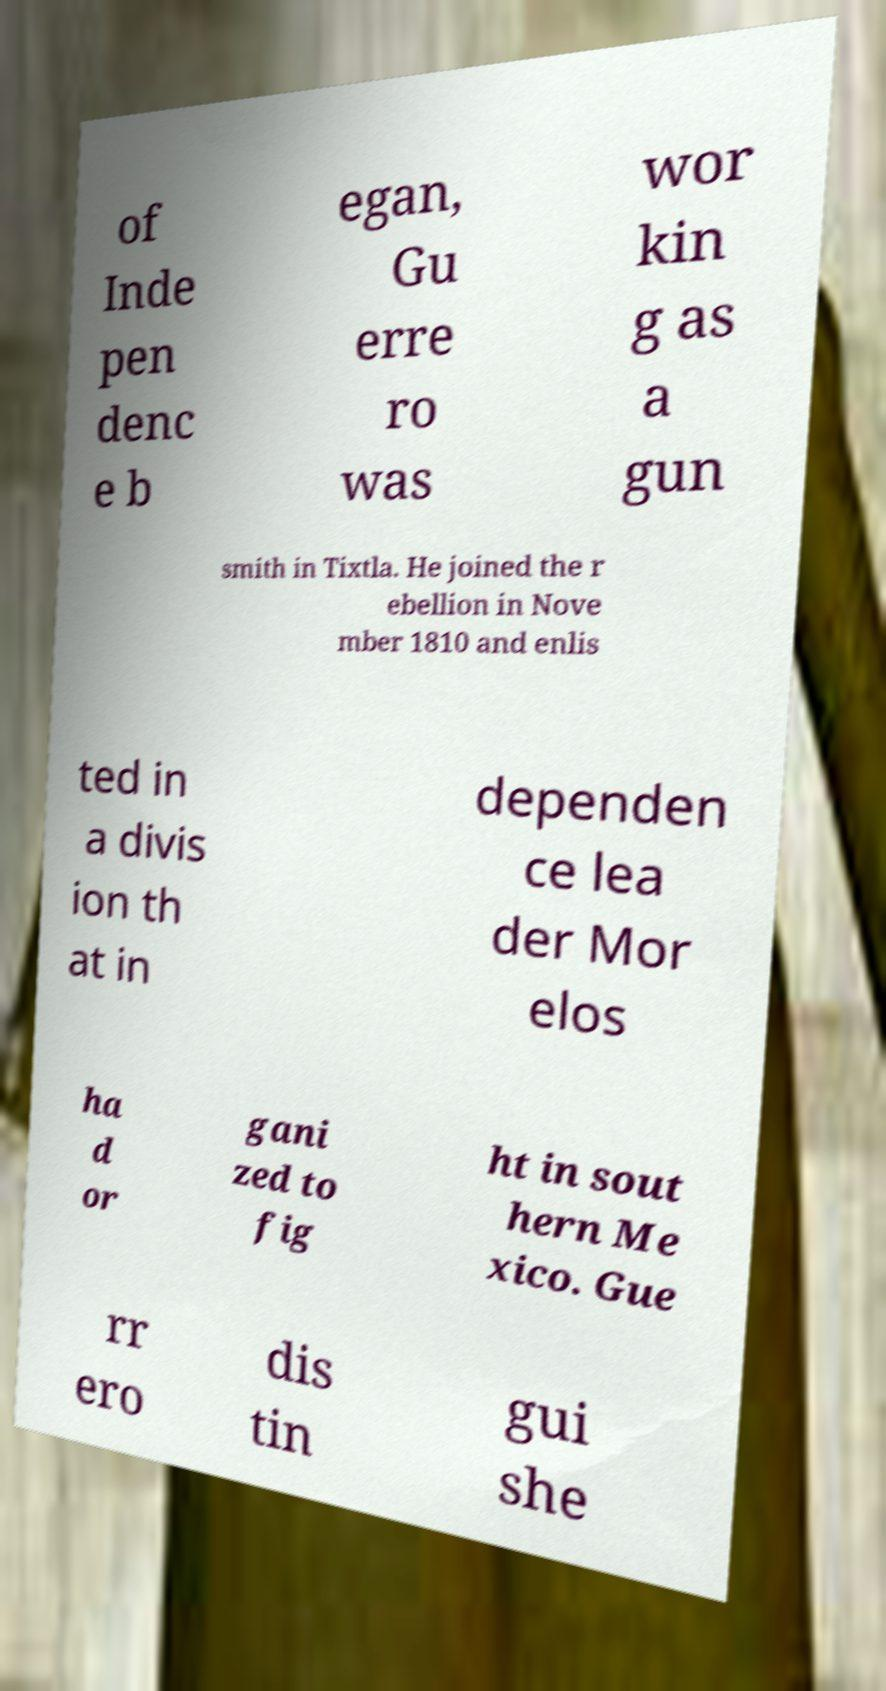Please identify and transcribe the text found in this image. of Inde pen denc e b egan, Gu erre ro was wor kin g as a gun smith in Tixtla. He joined the r ebellion in Nove mber 1810 and enlis ted in a divis ion th at in dependen ce lea der Mor elos ha d or gani zed to fig ht in sout hern Me xico. Gue rr ero dis tin gui she 